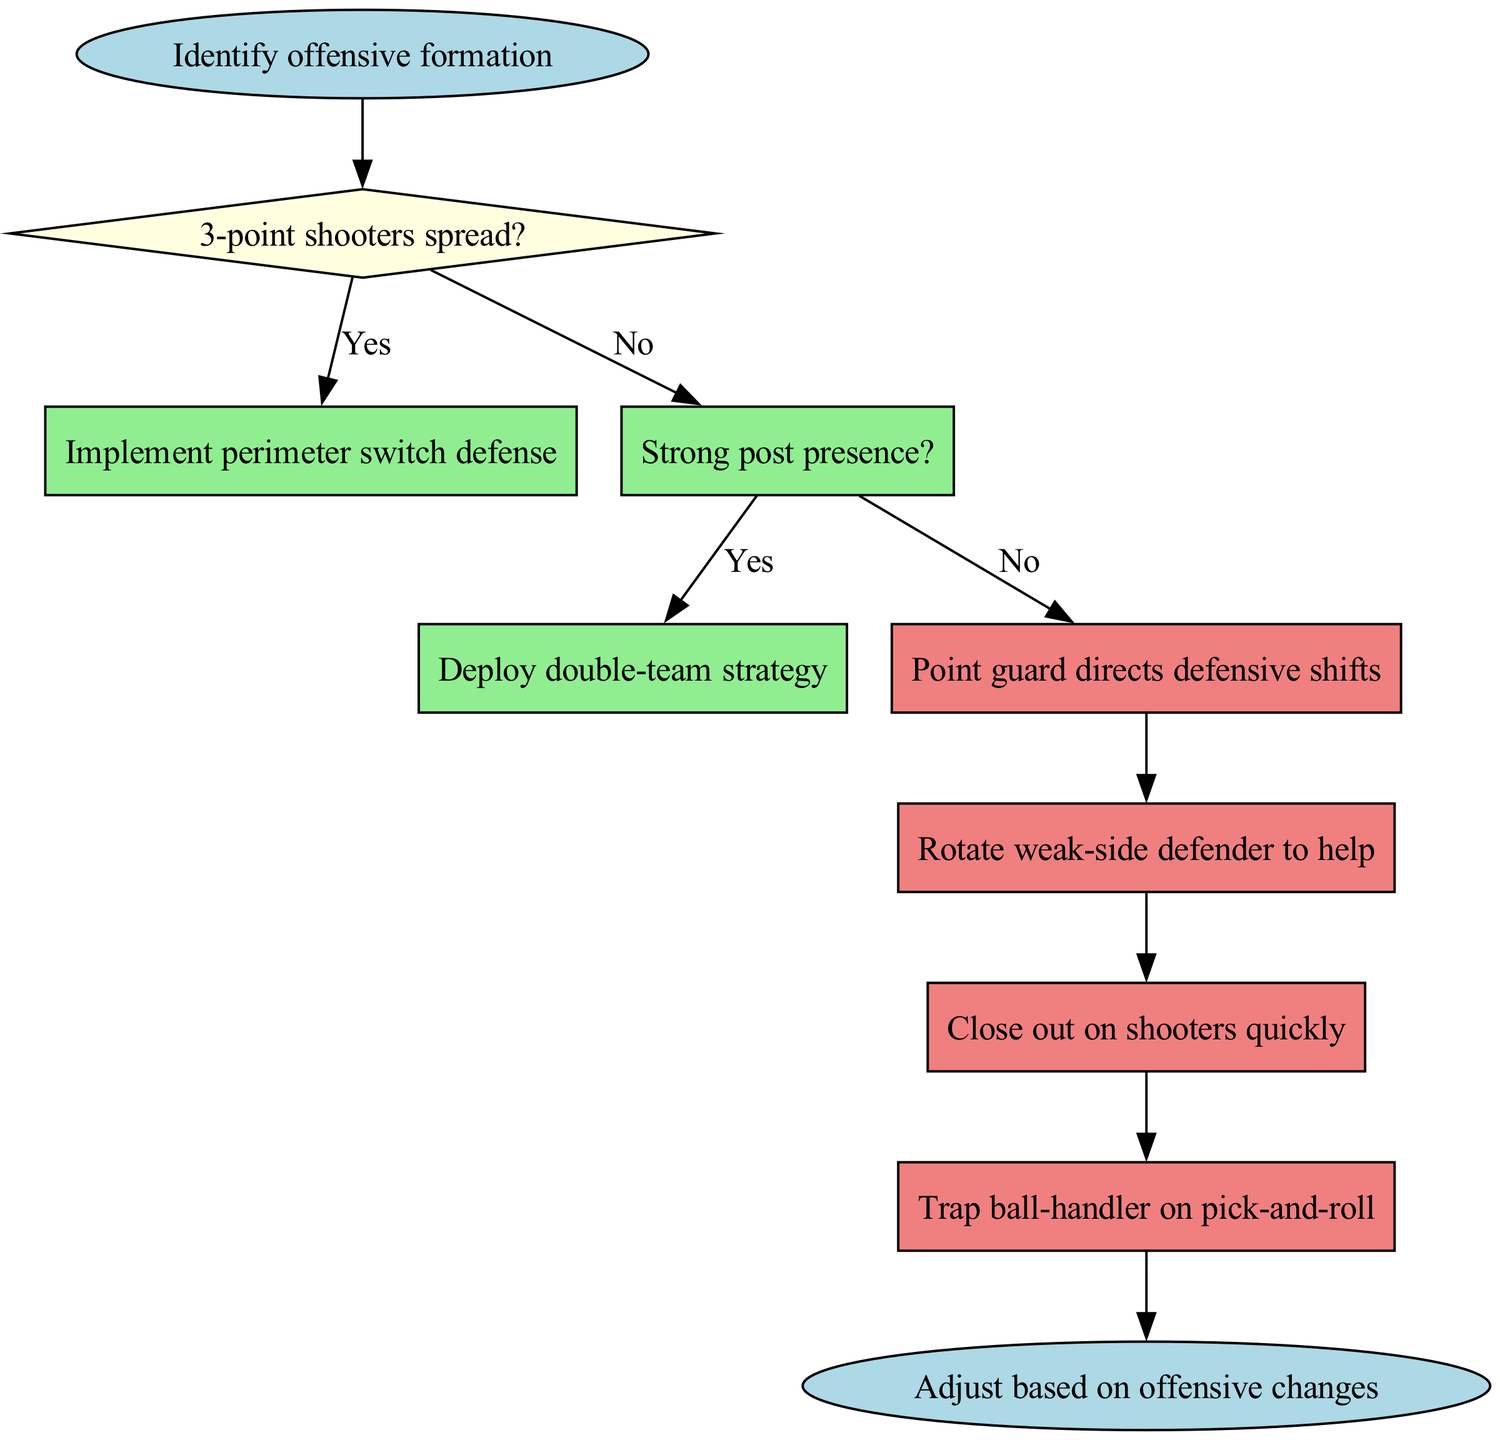What is the first action after identifying offensive formation? The diagram begins with the "Identify offensive formation" node. Following that, the decision regarding the 3-point shooters is made. If there is a presence of 3-point shooters, the next step would be implementing perimeter switch defense, but if not, it goes on to check for post presence.
Answer: Check for post presence How many decision nodes are in the diagram? The diagram contains two decision nodes: one for 3-point shooters spread and another for strong post presence. Each of these nodes leads to further actions or decisions.
Answer: 2 What action follows the deployment of the double-team strategy? After deploying the double-team strategy, the next actions outlined in the diagram will begin; specifically, a weak-side defender rotation will occur to assist defensively.
Answer: Rotate weak-side defender to help What happens if the answer to "Strong post presence?" is no? If "Strong post presence?" answers to no, the defensive strategy shifts to maintain man-to-man coverage as indicated by the flow from that decision node. It indicates a continuation of a specific defensive strategy rather than moving to other actions.
Answer: Maintain man-to-man coverage What are the last actions listed in the diagram? The actions listed in the diagram are in sequential order, and the last actions would be closing out on shooters quickly and trapping the ball handler on pick-and-roll. The diagram ends with an adjustment based on any changes made by the offense.
Answer: Trap ball-handler on pick-and-roll What should the point guard do at the start? According to the diagram, the point guard's primary role at the start of the defensive rotation is to direct defensive shifts based on the identified offensive formation, setting the tone for the team's defensive response.
Answer: Point guard directs defensive shifts 